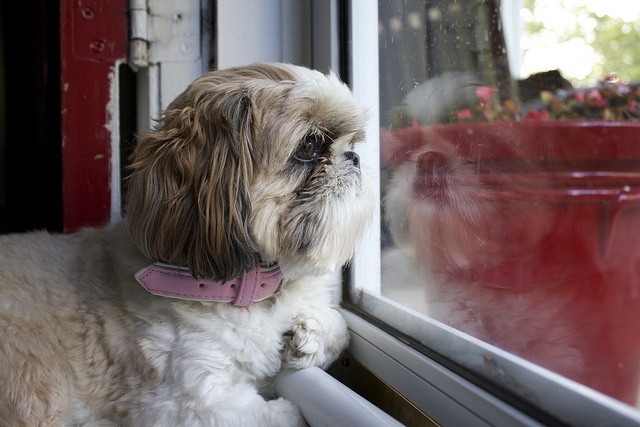Describe the objects in this image and their specific colors. I can see dog in black, gray, darkgray, and lightgray tones and potted plant in black, maroon, and brown tones in this image. 